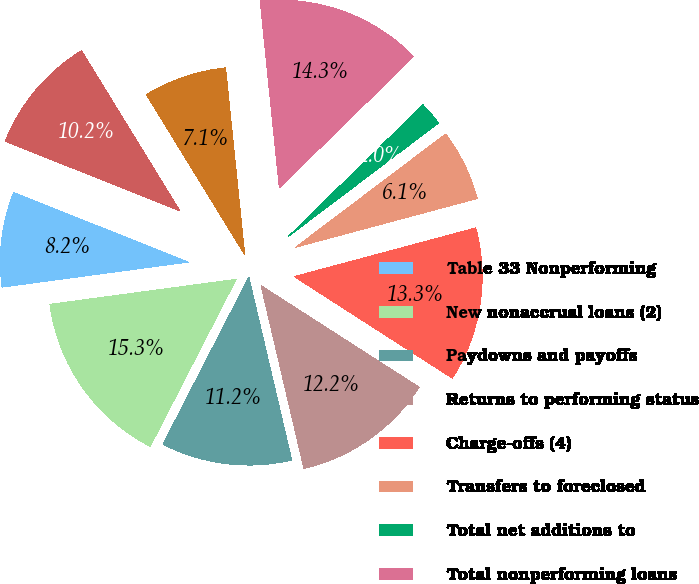Convert chart. <chart><loc_0><loc_0><loc_500><loc_500><pie_chart><fcel>Table 33 Nonperforming<fcel>New nonaccrual loans (2)<fcel>Paydowns and payoffs<fcel>Returns to performing status<fcel>Charge-offs (4)<fcel>Transfers to foreclosed<fcel>Total net additions to<fcel>Total nonperforming loans<fcel>Balance January 1<fcel>New foreclosed properties (6<nl><fcel>8.16%<fcel>15.31%<fcel>11.22%<fcel>12.24%<fcel>13.26%<fcel>6.12%<fcel>2.04%<fcel>14.29%<fcel>7.14%<fcel>10.2%<nl></chart> 